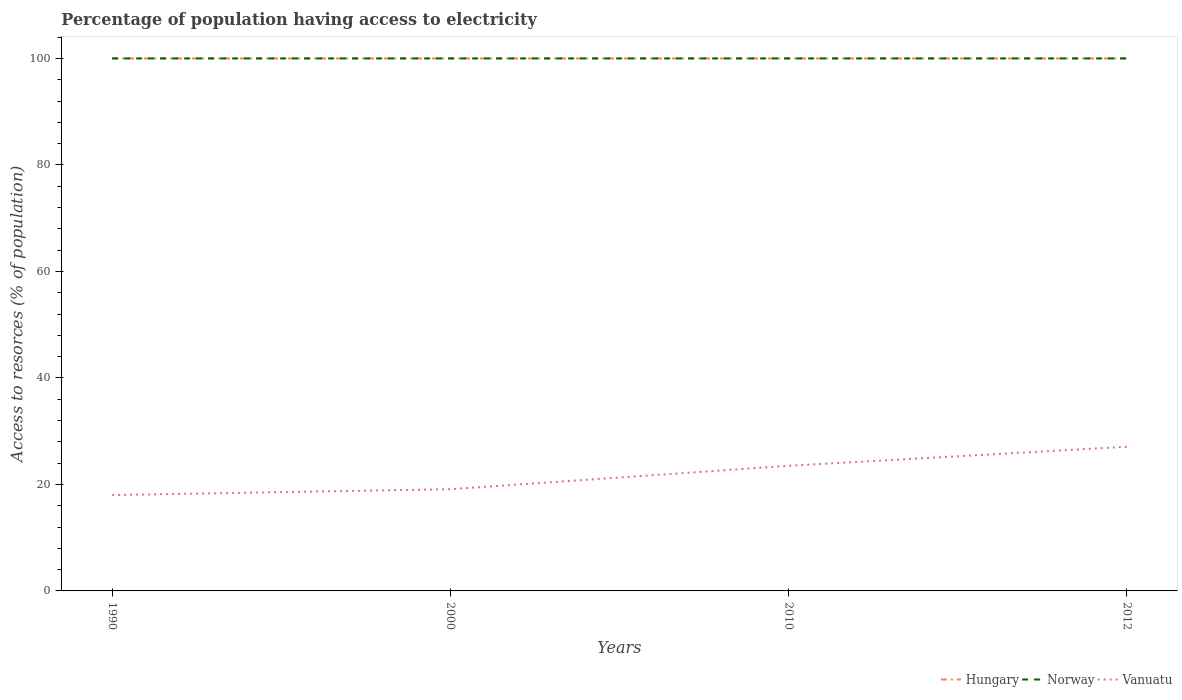Does the line corresponding to Hungary intersect with the line corresponding to Vanuatu?
Provide a short and direct response. No. Is the number of lines equal to the number of legend labels?
Provide a short and direct response. Yes. What is the total percentage of population having access to electricity in Hungary in the graph?
Give a very brief answer. 0. What is the difference between the highest and the second highest percentage of population having access to electricity in Norway?
Your answer should be compact. 0. Is the percentage of population having access to electricity in Hungary strictly greater than the percentage of population having access to electricity in Vanuatu over the years?
Make the answer very short. No. How many lines are there?
Give a very brief answer. 3. What is the difference between two consecutive major ticks on the Y-axis?
Provide a succinct answer. 20. Are the values on the major ticks of Y-axis written in scientific E-notation?
Provide a short and direct response. No. Does the graph contain any zero values?
Keep it short and to the point. No. Does the graph contain grids?
Your answer should be compact. No. How many legend labels are there?
Your response must be concise. 3. What is the title of the graph?
Provide a short and direct response. Percentage of population having access to electricity. Does "Guinea" appear as one of the legend labels in the graph?
Your answer should be very brief. No. What is the label or title of the X-axis?
Your answer should be compact. Years. What is the label or title of the Y-axis?
Offer a very short reply. Access to resorces (% of population). What is the Access to resorces (% of population) in Hungary in 1990?
Keep it short and to the point. 100. What is the Access to resorces (% of population) of Hungary in 2000?
Ensure brevity in your answer.  100. What is the Access to resorces (% of population) in Vanuatu in 2000?
Provide a short and direct response. 19.1. What is the Access to resorces (% of population) in Hungary in 2010?
Your response must be concise. 100. What is the Access to resorces (% of population) in Norway in 2010?
Your response must be concise. 100. What is the Access to resorces (% of population) in Hungary in 2012?
Your response must be concise. 100. What is the Access to resorces (% of population) of Vanuatu in 2012?
Offer a very short reply. 27.08. Across all years, what is the maximum Access to resorces (% of population) of Hungary?
Offer a terse response. 100. Across all years, what is the maximum Access to resorces (% of population) in Norway?
Your answer should be compact. 100. Across all years, what is the maximum Access to resorces (% of population) in Vanuatu?
Make the answer very short. 27.08. Across all years, what is the minimum Access to resorces (% of population) of Hungary?
Keep it short and to the point. 100. What is the total Access to resorces (% of population) in Norway in the graph?
Your answer should be compact. 400. What is the total Access to resorces (% of population) in Vanuatu in the graph?
Ensure brevity in your answer.  87.68. What is the difference between the Access to resorces (% of population) of Hungary in 1990 and that in 2000?
Provide a succinct answer. 0. What is the difference between the Access to resorces (% of population) in Vanuatu in 1990 and that in 2000?
Make the answer very short. -1.1. What is the difference between the Access to resorces (% of population) in Hungary in 1990 and that in 2010?
Provide a succinct answer. 0. What is the difference between the Access to resorces (% of population) in Vanuatu in 1990 and that in 2010?
Offer a terse response. -5.5. What is the difference between the Access to resorces (% of population) of Vanuatu in 1990 and that in 2012?
Give a very brief answer. -9.08. What is the difference between the Access to resorces (% of population) in Hungary in 2000 and that in 2010?
Provide a short and direct response. 0. What is the difference between the Access to resorces (% of population) in Norway in 2000 and that in 2012?
Your response must be concise. 0. What is the difference between the Access to resorces (% of population) in Vanuatu in 2000 and that in 2012?
Your response must be concise. -7.98. What is the difference between the Access to resorces (% of population) in Vanuatu in 2010 and that in 2012?
Provide a succinct answer. -3.58. What is the difference between the Access to resorces (% of population) of Hungary in 1990 and the Access to resorces (% of population) of Vanuatu in 2000?
Ensure brevity in your answer.  80.9. What is the difference between the Access to resorces (% of population) in Norway in 1990 and the Access to resorces (% of population) in Vanuatu in 2000?
Your response must be concise. 80.9. What is the difference between the Access to resorces (% of population) in Hungary in 1990 and the Access to resorces (% of population) in Vanuatu in 2010?
Ensure brevity in your answer.  76.5. What is the difference between the Access to resorces (% of population) of Norway in 1990 and the Access to resorces (% of population) of Vanuatu in 2010?
Ensure brevity in your answer.  76.5. What is the difference between the Access to resorces (% of population) in Hungary in 1990 and the Access to resorces (% of population) in Vanuatu in 2012?
Give a very brief answer. 72.92. What is the difference between the Access to resorces (% of population) in Norway in 1990 and the Access to resorces (% of population) in Vanuatu in 2012?
Give a very brief answer. 72.92. What is the difference between the Access to resorces (% of population) in Hungary in 2000 and the Access to resorces (% of population) in Vanuatu in 2010?
Make the answer very short. 76.5. What is the difference between the Access to resorces (% of population) of Norway in 2000 and the Access to resorces (% of population) of Vanuatu in 2010?
Give a very brief answer. 76.5. What is the difference between the Access to resorces (% of population) in Hungary in 2000 and the Access to resorces (% of population) in Norway in 2012?
Offer a very short reply. 0. What is the difference between the Access to resorces (% of population) in Hungary in 2000 and the Access to resorces (% of population) in Vanuatu in 2012?
Offer a terse response. 72.92. What is the difference between the Access to resorces (% of population) in Norway in 2000 and the Access to resorces (% of population) in Vanuatu in 2012?
Offer a terse response. 72.92. What is the difference between the Access to resorces (% of population) in Hungary in 2010 and the Access to resorces (% of population) in Norway in 2012?
Provide a short and direct response. 0. What is the difference between the Access to resorces (% of population) in Hungary in 2010 and the Access to resorces (% of population) in Vanuatu in 2012?
Keep it short and to the point. 72.92. What is the difference between the Access to resorces (% of population) in Norway in 2010 and the Access to resorces (% of population) in Vanuatu in 2012?
Make the answer very short. 72.92. What is the average Access to resorces (% of population) in Hungary per year?
Your answer should be very brief. 100. What is the average Access to resorces (% of population) of Norway per year?
Your answer should be compact. 100. What is the average Access to resorces (% of population) in Vanuatu per year?
Your response must be concise. 21.92. In the year 2000, what is the difference between the Access to resorces (% of population) in Hungary and Access to resorces (% of population) in Norway?
Offer a terse response. 0. In the year 2000, what is the difference between the Access to resorces (% of population) of Hungary and Access to resorces (% of population) of Vanuatu?
Ensure brevity in your answer.  80.9. In the year 2000, what is the difference between the Access to resorces (% of population) in Norway and Access to resorces (% of population) in Vanuatu?
Your answer should be compact. 80.9. In the year 2010, what is the difference between the Access to resorces (% of population) of Hungary and Access to resorces (% of population) of Norway?
Your response must be concise. 0. In the year 2010, what is the difference between the Access to resorces (% of population) in Hungary and Access to resorces (% of population) in Vanuatu?
Your answer should be compact. 76.5. In the year 2010, what is the difference between the Access to resorces (% of population) of Norway and Access to resorces (% of population) of Vanuatu?
Your answer should be compact. 76.5. In the year 2012, what is the difference between the Access to resorces (% of population) of Hungary and Access to resorces (% of population) of Vanuatu?
Ensure brevity in your answer.  72.92. In the year 2012, what is the difference between the Access to resorces (% of population) of Norway and Access to resorces (% of population) of Vanuatu?
Ensure brevity in your answer.  72.92. What is the ratio of the Access to resorces (% of population) in Hungary in 1990 to that in 2000?
Ensure brevity in your answer.  1. What is the ratio of the Access to resorces (% of population) of Norway in 1990 to that in 2000?
Your response must be concise. 1. What is the ratio of the Access to resorces (% of population) of Vanuatu in 1990 to that in 2000?
Ensure brevity in your answer.  0.94. What is the ratio of the Access to resorces (% of population) of Hungary in 1990 to that in 2010?
Offer a terse response. 1. What is the ratio of the Access to resorces (% of population) in Norway in 1990 to that in 2010?
Ensure brevity in your answer.  1. What is the ratio of the Access to resorces (% of population) in Vanuatu in 1990 to that in 2010?
Your answer should be compact. 0.77. What is the ratio of the Access to resorces (% of population) in Vanuatu in 1990 to that in 2012?
Your response must be concise. 0.66. What is the ratio of the Access to resorces (% of population) of Vanuatu in 2000 to that in 2010?
Your answer should be compact. 0.81. What is the ratio of the Access to resorces (% of population) of Hungary in 2000 to that in 2012?
Keep it short and to the point. 1. What is the ratio of the Access to resorces (% of population) of Vanuatu in 2000 to that in 2012?
Ensure brevity in your answer.  0.71. What is the ratio of the Access to resorces (% of population) in Vanuatu in 2010 to that in 2012?
Give a very brief answer. 0.87. What is the difference between the highest and the second highest Access to resorces (% of population) in Hungary?
Ensure brevity in your answer.  0. What is the difference between the highest and the second highest Access to resorces (% of population) of Norway?
Your answer should be very brief. 0. What is the difference between the highest and the second highest Access to resorces (% of population) in Vanuatu?
Keep it short and to the point. 3.58. What is the difference between the highest and the lowest Access to resorces (% of population) in Vanuatu?
Keep it short and to the point. 9.08. 